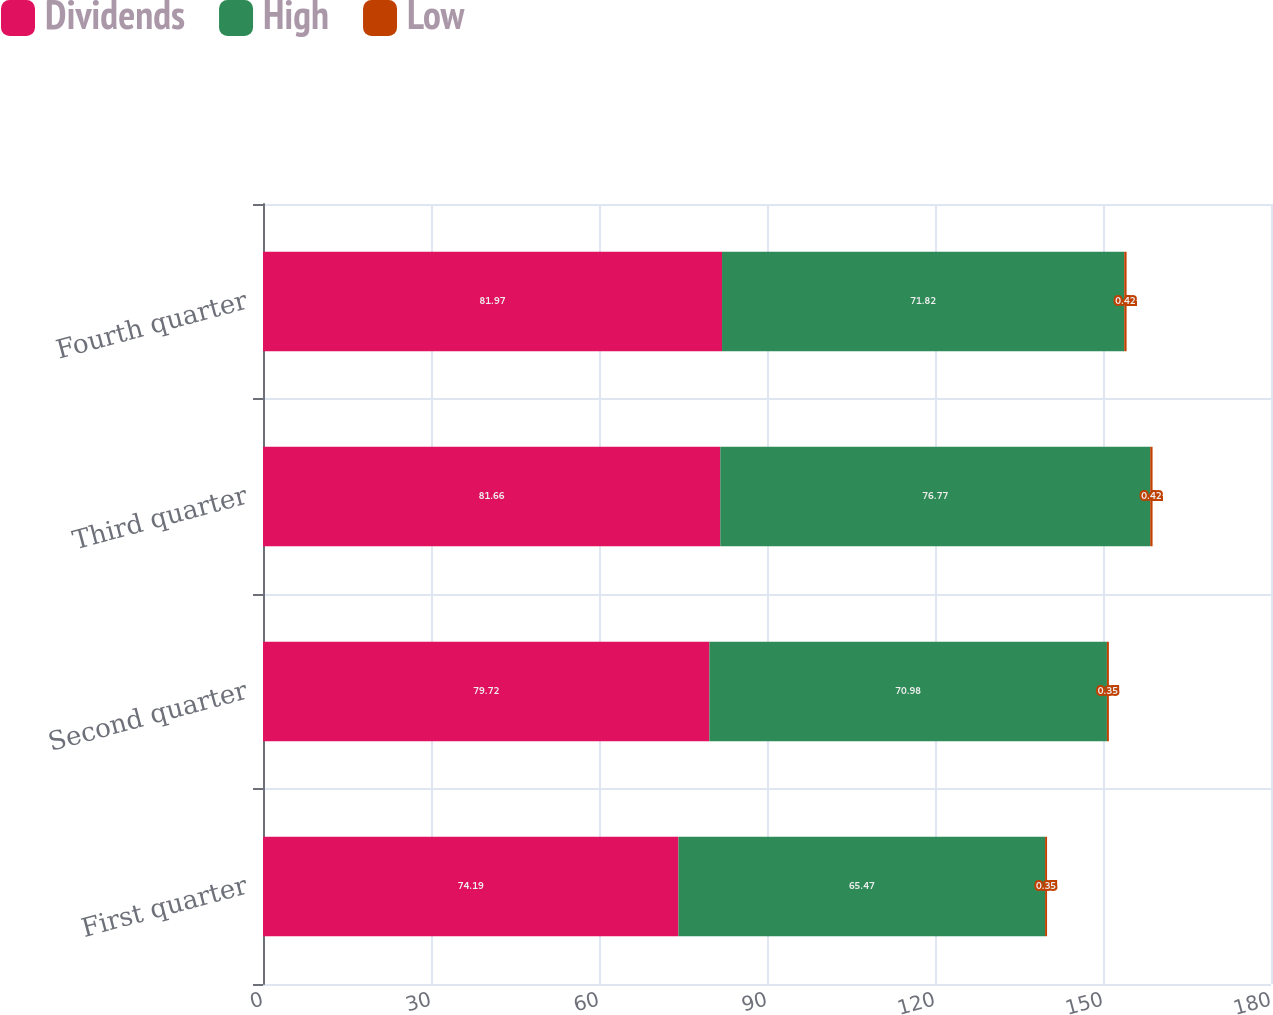Convert chart to OTSL. <chart><loc_0><loc_0><loc_500><loc_500><stacked_bar_chart><ecel><fcel>First quarter<fcel>Second quarter<fcel>Third quarter<fcel>Fourth quarter<nl><fcel>Dividends<fcel>74.19<fcel>79.72<fcel>81.66<fcel>81.97<nl><fcel>High<fcel>65.47<fcel>70.98<fcel>76.77<fcel>71.82<nl><fcel>Low<fcel>0.35<fcel>0.35<fcel>0.42<fcel>0.42<nl></chart> 